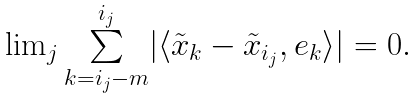<formula> <loc_0><loc_0><loc_500><loc_500>\begin{array} { c } \lim _ { j } \underset { k = i _ { j } - m } { \overset { i _ { j } } { \sum } } | \langle \tilde { x } _ { k } - \tilde { x } _ { i _ { j } } , e _ { k } \rangle | = 0 . \end{array}</formula> 